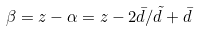<formula> <loc_0><loc_0><loc_500><loc_500>\beta = z - \alpha = z - 2 \bar { d } / { \tilde { d } } + \bar { d }</formula> 